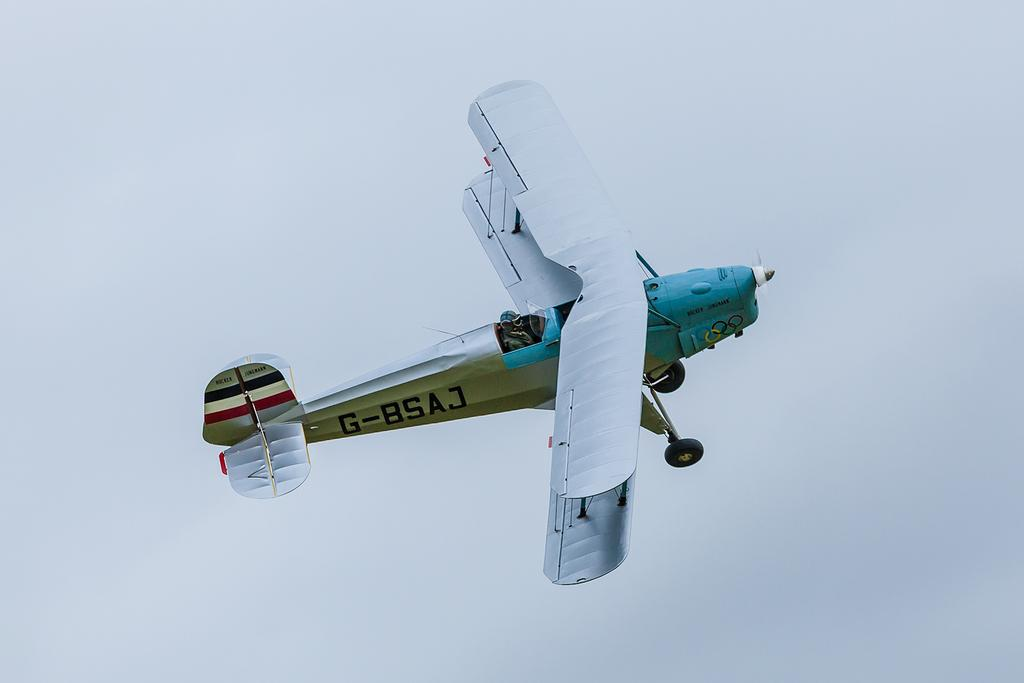Who is present in the image? There is a person in the image. What is the person doing in the image? The person is sitting in an airplane. Where is the airplane located in the image? The airplane is flying in the sky. What type of mist can be seen coming from the person's lips in the image? There is no mist or reference to lips in the image; it features a person sitting in an airplane flying in the sky. 